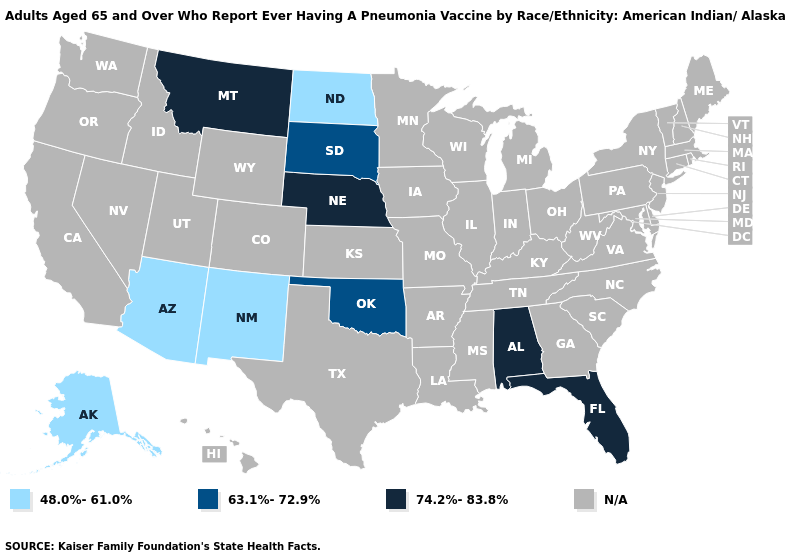Name the states that have a value in the range 74.2%-83.8%?
Keep it brief. Alabama, Florida, Montana, Nebraska. Name the states that have a value in the range 63.1%-72.9%?
Keep it brief. Oklahoma, South Dakota. Name the states that have a value in the range N/A?
Write a very short answer. Arkansas, California, Colorado, Connecticut, Delaware, Georgia, Hawaii, Idaho, Illinois, Indiana, Iowa, Kansas, Kentucky, Louisiana, Maine, Maryland, Massachusetts, Michigan, Minnesota, Mississippi, Missouri, Nevada, New Hampshire, New Jersey, New York, North Carolina, Ohio, Oregon, Pennsylvania, Rhode Island, South Carolina, Tennessee, Texas, Utah, Vermont, Virginia, Washington, West Virginia, Wisconsin, Wyoming. Name the states that have a value in the range 63.1%-72.9%?
Quick response, please. Oklahoma, South Dakota. What is the value of Arizona?
Give a very brief answer. 48.0%-61.0%. Among the states that border Nevada , which have the lowest value?
Give a very brief answer. Arizona. What is the value of Arizona?
Answer briefly. 48.0%-61.0%. Name the states that have a value in the range 63.1%-72.9%?
Be succinct. Oklahoma, South Dakota. Name the states that have a value in the range 48.0%-61.0%?
Answer briefly. Alaska, Arizona, New Mexico, North Dakota. Which states hav the highest value in the MidWest?
Write a very short answer. Nebraska. What is the value of Massachusetts?
Quick response, please. N/A. Which states hav the highest value in the West?
Short answer required. Montana. Does Oklahoma have the lowest value in the USA?
Be succinct. No. Name the states that have a value in the range N/A?
Answer briefly. Arkansas, California, Colorado, Connecticut, Delaware, Georgia, Hawaii, Idaho, Illinois, Indiana, Iowa, Kansas, Kentucky, Louisiana, Maine, Maryland, Massachusetts, Michigan, Minnesota, Mississippi, Missouri, Nevada, New Hampshire, New Jersey, New York, North Carolina, Ohio, Oregon, Pennsylvania, Rhode Island, South Carolina, Tennessee, Texas, Utah, Vermont, Virginia, Washington, West Virginia, Wisconsin, Wyoming. 